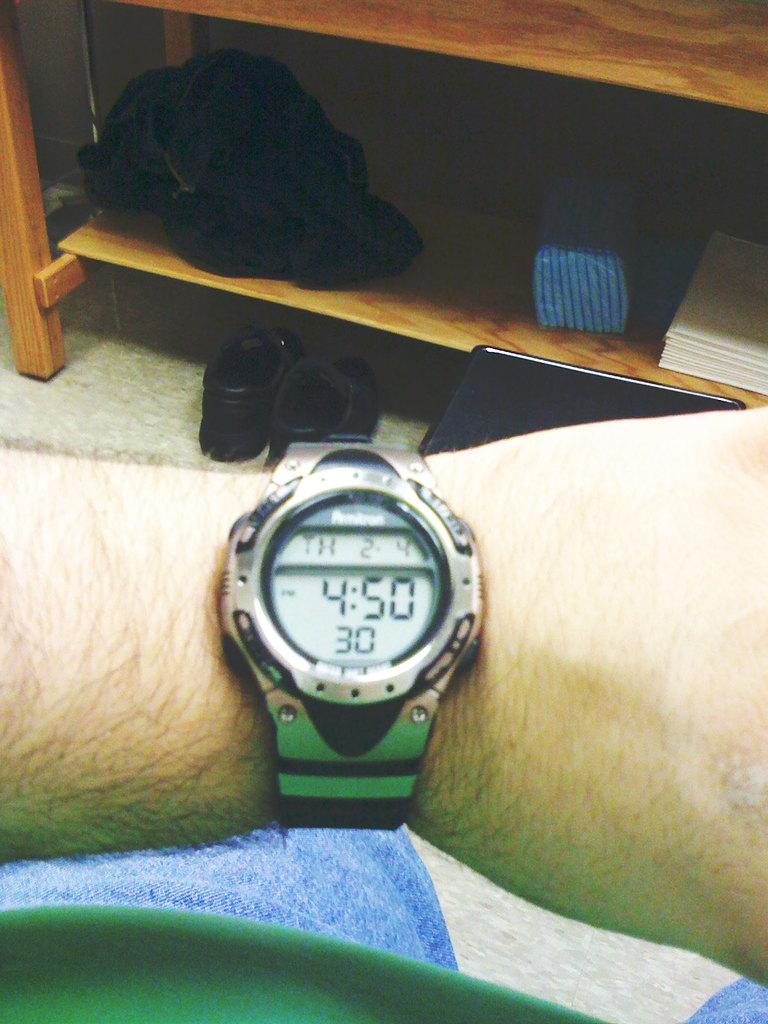<image>
Provide a brief description of the given image. A digital watch shows a time of 4:50 and has the date on it as well. 